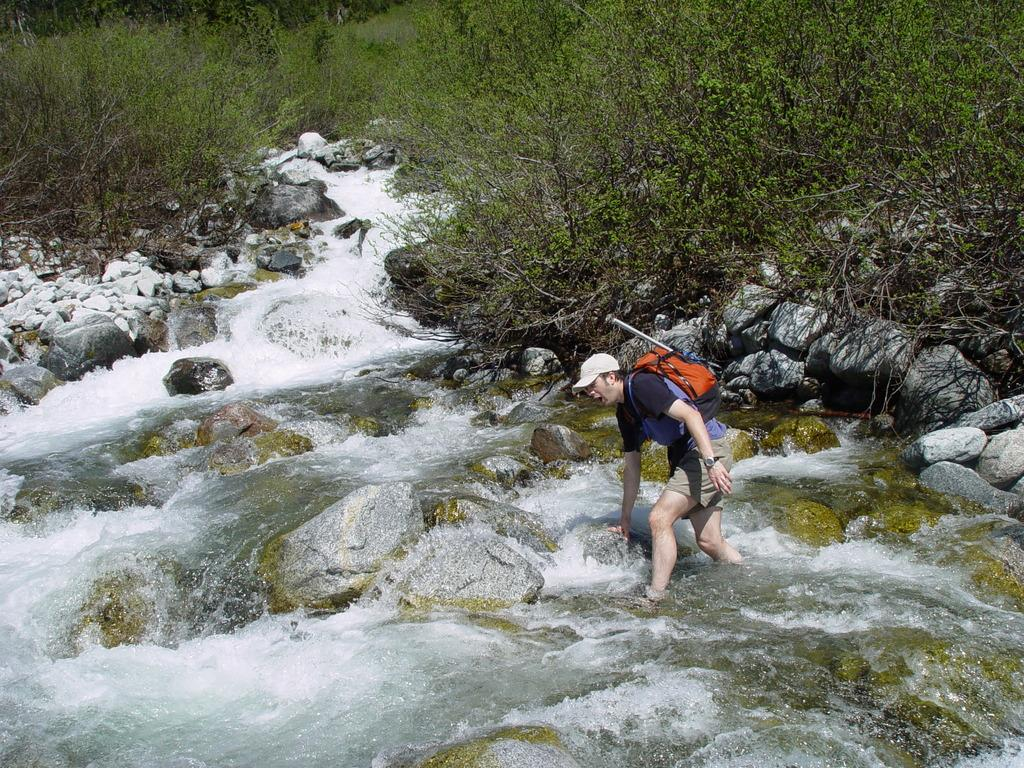Who is the main subject in the image? There is a man in the center of the image. What is the man wearing on his body? The man is wearing a bag. What type of headwear is the man wearing? The man is wearing a hat. What can be seen in the background of the image? Water, rocks, and trees are present in the background of the image. What is the process of the man sneezing in the image? There is no indication in the image that the man is sneezing, so it cannot be determined from the picture. 